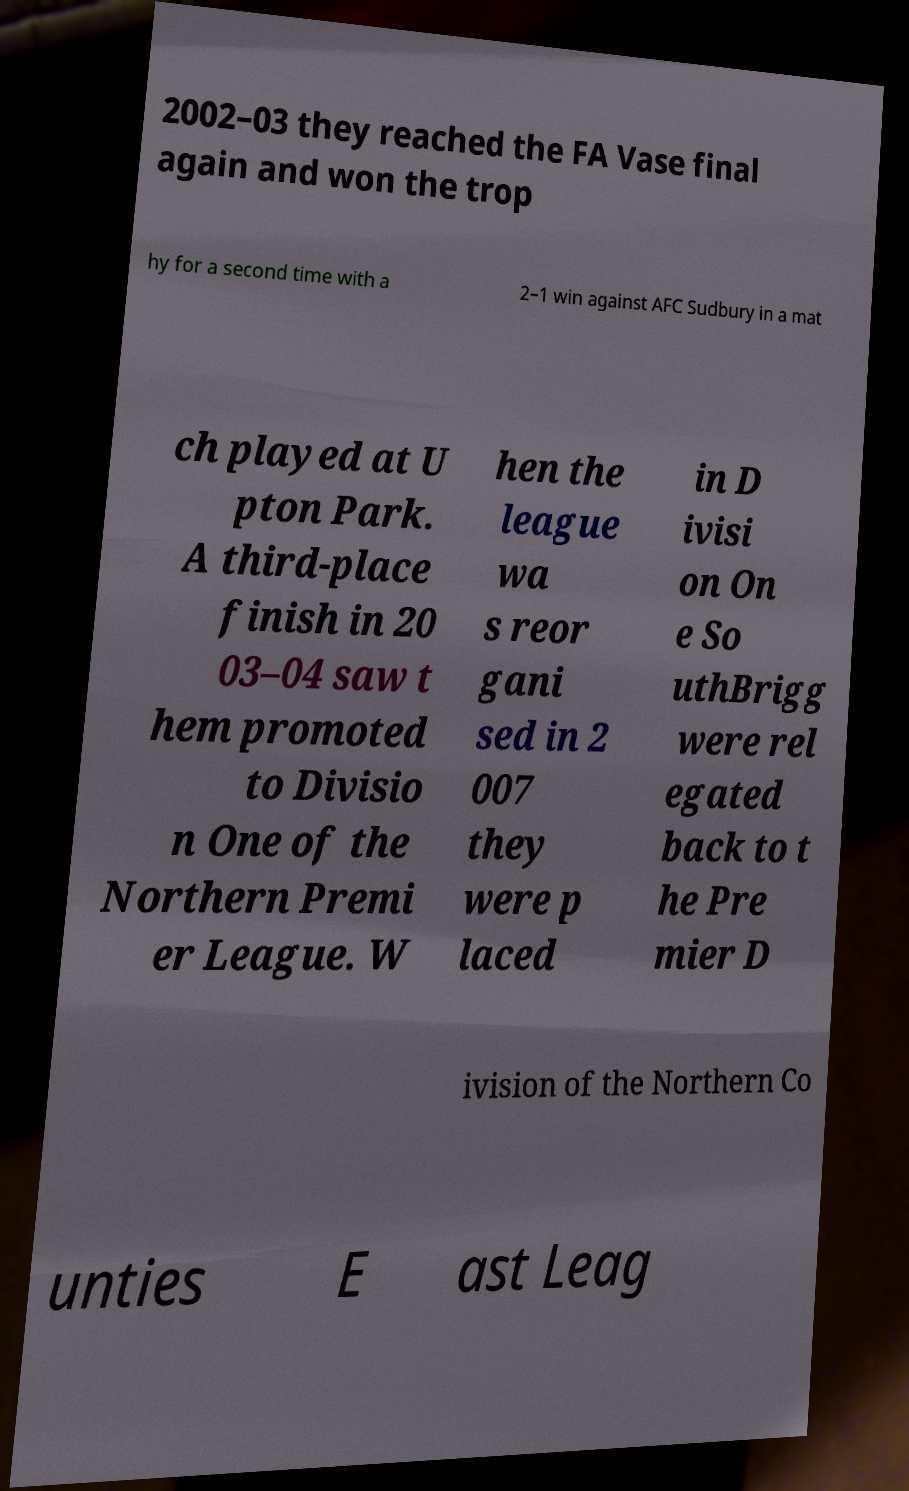I need the written content from this picture converted into text. Can you do that? 2002–03 they reached the FA Vase final again and won the trop hy for a second time with a 2–1 win against AFC Sudbury in a mat ch played at U pton Park. A third-place finish in 20 03–04 saw t hem promoted to Divisio n One of the Northern Premi er League. W hen the league wa s reor gani sed in 2 007 they were p laced in D ivisi on On e So uthBrigg were rel egated back to t he Pre mier D ivision of the Northern Co unties E ast Leag 